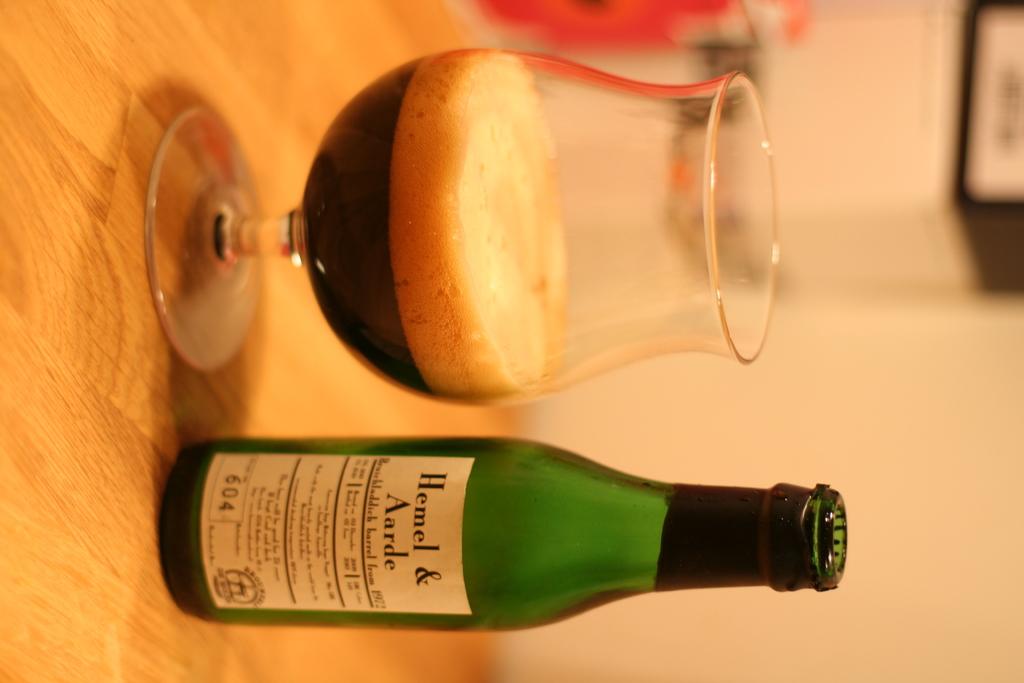What kind of drink is this?
Keep it short and to the point. Hemel & aarde. What number is on the bottom left corner of the label?
Ensure brevity in your answer.  604. 